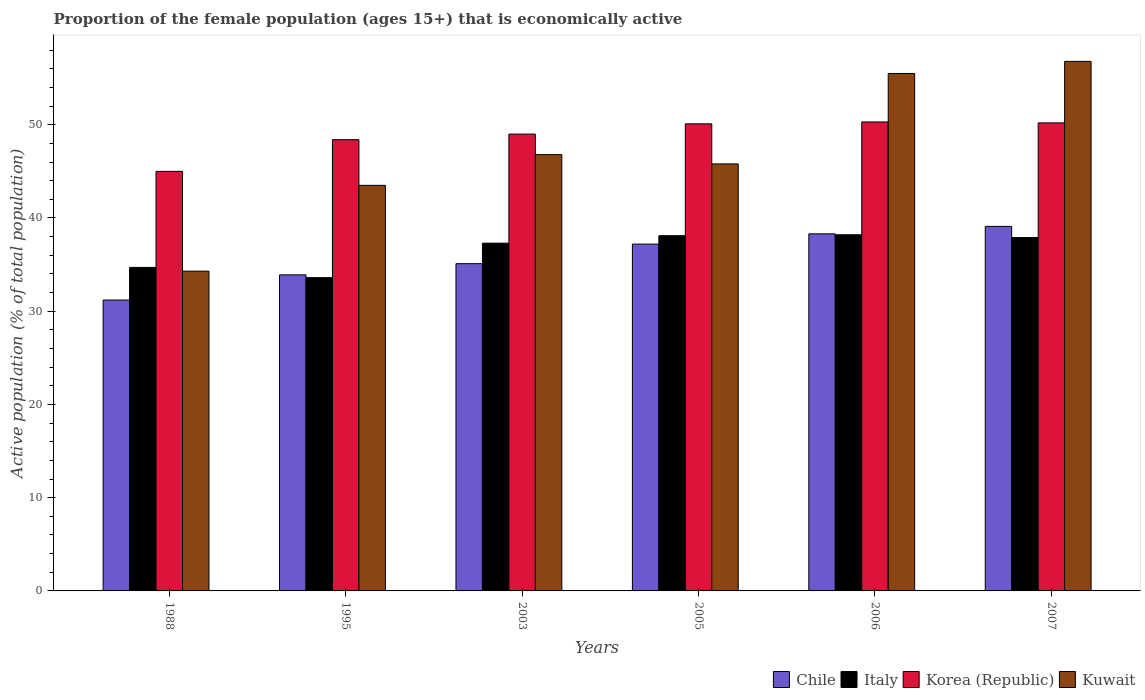Are the number of bars per tick equal to the number of legend labels?
Give a very brief answer. Yes. How many bars are there on the 1st tick from the right?
Your response must be concise. 4. In how many cases, is the number of bars for a given year not equal to the number of legend labels?
Ensure brevity in your answer.  0. What is the proportion of the female population that is economically active in Chile in 2006?
Keep it short and to the point. 38.3. Across all years, what is the maximum proportion of the female population that is economically active in Kuwait?
Offer a very short reply. 56.8. What is the total proportion of the female population that is economically active in Kuwait in the graph?
Provide a succinct answer. 282.7. What is the difference between the proportion of the female population that is economically active in Korea (Republic) in 2005 and that in 2006?
Provide a succinct answer. -0.2. What is the difference between the proportion of the female population that is economically active in Korea (Republic) in 2007 and the proportion of the female population that is economically active in Chile in 2005?
Your answer should be compact. 13. What is the average proportion of the female population that is economically active in Kuwait per year?
Your answer should be very brief. 47.12. In the year 2006, what is the difference between the proportion of the female population that is economically active in Kuwait and proportion of the female population that is economically active in Korea (Republic)?
Keep it short and to the point. 5.2. What is the ratio of the proportion of the female population that is economically active in Chile in 2006 to that in 2007?
Offer a terse response. 0.98. What is the difference between the highest and the second highest proportion of the female population that is economically active in Korea (Republic)?
Offer a very short reply. 0.1. What is the difference between the highest and the lowest proportion of the female population that is economically active in Italy?
Offer a terse response. 4.6. In how many years, is the proportion of the female population that is economically active in Chile greater than the average proportion of the female population that is economically active in Chile taken over all years?
Provide a short and direct response. 3. Is it the case that in every year, the sum of the proportion of the female population that is economically active in Kuwait and proportion of the female population that is economically active in Korea (Republic) is greater than the sum of proportion of the female population that is economically active in Italy and proportion of the female population that is economically active in Chile?
Offer a very short reply. No. What does the 4th bar from the left in 2006 represents?
Ensure brevity in your answer.  Kuwait. What does the 2nd bar from the right in 2007 represents?
Your response must be concise. Korea (Republic). Is it the case that in every year, the sum of the proportion of the female population that is economically active in Kuwait and proportion of the female population that is economically active in Italy is greater than the proportion of the female population that is economically active in Korea (Republic)?
Your answer should be very brief. Yes. How many bars are there?
Your response must be concise. 24. How many years are there in the graph?
Offer a very short reply. 6. What is the difference between two consecutive major ticks on the Y-axis?
Your response must be concise. 10. Does the graph contain any zero values?
Your answer should be compact. No. How are the legend labels stacked?
Provide a succinct answer. Horizontal. What is the title of the graph?
Provide a short and direct response. Proportion of the female population (ages 15+) that is economically active. Does "St. Martin (French part)" appear as one of the legend labels in the graph?
Provide a short and direct response. No. What is the label or title of the Y-axis?
Give a very brief answer. Active population (% of total population). What is the Active population (% of total population) in Chile in 1988?
Your response must be concise. 31.2. What is the Active population (% of total population) in Italy in 1988?
Keep it short and to the point. 34.7. What is the Active population (% of total population) in Kuwait in 1988?
Your response must be concise. 34.3. What is the Active population (% of total population) of Chile in 1995?
Provide a succinct answer. 33.9. What is the Active population (% of total population) in Italy in 1995?
Offer a very short reply. 33.6. What is the Active population (% of total population) in Korea (Republic) in 1995?
Provide a succinct answer. 48.4. What is the Active population (% of total population) of Kuwait in 1995?
Your response must be concise. 43.5. What is the Active population (% of total population) in Chile in 2003?
Provide a succinct answer. 35.1. What is the Active population (% of total population) in Italy in 2003?
Keep it short and to the point. 37.3. What is the Active population (% of total population) of Kuwait in 2003?
Offer a terse response. 46.8. What is the Active population (% of total population) in Chile in 2005?
Provide a short and direct response. 37.2. What is the Active population (% of total population) in Italy in 2005?
Give a very brief answer. 38.1. What is the Active population (% of total population) in Korea (Republic) in 2005?
Give a very brief answer. 50.1. What is the Active population (% of total population) of Kuwait in 2005?
Provide a short and direct response. 45.8. What is the Active population (% of total population) of Chile in 2006?
Keep it short and to the point. 38.3. What is the Active population (% of total population) in Italy in 2006?
Provide a short and direct response. 38.2. What is the Active population (% of total population) in Korea (Republic) in 2006?
Offer a very short reply. 50.3. What is the Active population (% of total population) of Kuwait in 2006?
Provide a short and direct response. 55.5. What is the Active population (% of total population) of Chile in 2007?
Make the answer very short. 39.1. What is the Active population (% of total population) of Italy in 2007?
Your answer should be compact. 37.9. What is the Active population (% of total population) in Korea (Republic) in 2007?
Make the answer very short. 50.2. What is the Active population (% of total population) of Kuwait in 2007?
Offer a very short reply. 56.8. Across all years, what is the maximum Active population (% of total population) of Chile?
Offer a very short reply. 39.1. Across all years, what is the maximum Active population (% of total population) in Italy?
Your answer should be very brief. 38.2. Across all years, what is the maximum Active population (% of total population) in Korea (Republic)?
Your answer should be very brief. 50.3. Across all years, what is the maximum Active population (% of total population) of Kuwait?
Your answer should be very brief. 56.8. Across all years, what is the minimum Active population (% of total population) of Chile?
Keep it short and to the point. 31.2. Across all years, what is the minimum Active population (% of total population) in Italy?
Give a very brief answer. 33.6. Across all years, what is the minimum Active population (% of total population) in Kuwait?
Offer a terse response. 34.3. What is the total Active population (% of total population) in Chile in the graph?
Keep it short and to the point. 214.8. What is the total Active population (% of total population) in Italy in the graph?
Make the answer very short. 219.8. What is the total Active population (% of total population) in Korea (Republic) in the graph?
Offer a very short reply. 293. What is the total Active population (% of total population) of Kuwait in the graph?
Ensure brevity in your answer.  282.7. What is the difference between the Active population (% of total population) in Chile in 1988 and that in 1995?
Make the answer very short. -2.7. What is the difference between the Active population (% of total population) of Korea (Republic) in 1988 and that in 1995?
Your response must be concise. -3.4. What is the difference between the Active population (% of total population) in Italy in 1988 and that in 2003?
Your answer should be very brief. -2.6. What is the difference between the Active population (% of total population) of Korea (Republic) in 1988 and that in 2003?
Your answer should be very brief. -4. What is the difference between the Active population (% of total population) of Kuwait in 1988 and that in 2003?
Provide a short and direct response. -12.5. What is the difference between the Active population (% of total population) of Korea (Republic) in 1988 and that in 2005?
Ensure brevity in your answer.  -5.1. What is the difference between the Active population (% of total population) of Kuwait in 1988 and that in 2005?
Provide a short and direct response. -11.5. What is the difference between the Active population (% of total population) of Italy in 1988 and that in 2006?
Give a very brief answer. -3.5. What is the difference between the Active population (% of total population) in Kuwait in 1988 and that in 2006?
Your answer should be compact. -21.2. What is the difference between the Active population (% of total population) in Italy in 1988 and that in 2007?
Provide a short and direct response. -3.2. What is the difference between the Active population (% of total population) in Kuwait in 1988 and that in 2007?
Make the answer very short. -22.5. What is the difference between the Active population (% of total population) in Chile in 1995 and that in 2003?
Offer a very short reply. -1.2. What is the difference between the Active population (% of total population) in Italy in 1995 and that in 2003?
Provide a short and direct response. -3.7. What is the difference between the Active population (% of total population) in Kuwait in 1995 and that in 2003?
Offer a terse response. -3.3. What is the difference between the Active population (% of total population) of Italy in 1995 and that in 2005?
Your response must be concise. -4.5. What is the difference between the Active population (% of total population) in Korea (Republic) in 1995 and that in 2005?
Make the answer very short. -1.7. What is the difference between the Active population (% of total population) in Italy in 1995 and that in 2006?
Ensure brevity in your answer.  -4.6. What is the difference between the Active population (% of total population) of Korea (Republic) in 1995 and that in 2006?
Offer a very short reply. -1.9. What is the difference between the Active population (% of total population) in Kuwait in 1995 and that in 2006?
Keep it short and to the point. -12. What is the difference between the Active population (% of total population) of Chile in 2003 and that in 2005?
Your answer should be very brief. -2.1. What is the difference between the Active population (% of total population) in Korea (Republic) in 2003 and that in 2006?
Ensure brevity in your answer.  -1.3. What is the difference between the Active population (% of total population) of Italy in 2003 and that in 2007?
Give a very brief answer. -0.6. What is the difference between the Active population (% of total population) of Korea (Republic) in 2003 and that in 2007?
Provide a short and direct response. -1.2. What is the difference between the Active population (% of total population) in Chile in 2005 and that in 2006?
Provide a short and direct response. -1.1. What is the difference between the Active population (% of total population) in Korea (Republic) in 2005 and that in 2006?
Offer a very short reply. -0.2. What is the difference between the Active population (% of total population) of Chile in 2005 and that in 2007?
Keep it short and to the point. -1.9. What is the difference between the Active population (% of total population) of Italy in 2005 and that in 2007?
Keep it short and to the point. 0.2. What is the difference between the Active population (% of total population) of Kuwait in 2005 and that in 2007?
Provide a short and direct response. -11. What is the difference between the Active population (% of total population) in Italy in 2006 and that in 2007?
Make the answer very short. 0.3. What is the difference between the Active population (% of total population) of Korea (Republic) in 2006 and that in 2007?
Provide a succinct answer. 0.1. What is the difference between the Active population (% of total population) in Chile in 1988 and the Active population (% of total population) in Italy in 1995?
Provide a short and direct response. -2.4. What is the difference between the Active population (% of total population) in Chile in 1988 and the Active population (% of total population) in Korea (Republic) in 1995?
Offer a very short reply. -17.2. What is the difference between the Active population (% of total population) of Italy in 1988 and the Active population (% of total population) of Korea (Republic) in 1995?
Make the answer very short. -13.7. What is the difference between the Active population (% of total population) of Korea (Republic) in 1988 and the Active population (% of total population) of Kuwait in 1995?
Offer a terse response. 1.5. What is the difference between the Active population (% of total population) of Chile in 1988 and the Active population (% of total population) of Korea (Republic) in 2003?
Provide a short and direct response. -17.8. What is the difference between the Active population (% of total population) in Chile in 1988 and the Active population (% of total population) in Kuwait in 2003?
Provide a short and direct response. -15.6. What is the difference between the Active population (% of total population) in Italy in 1988 and the Active population (% of total population) in Korea (Republic) in 2003?
Your answer should be compact. -14.3. What is the difference between the Active population (% of total population) in Korea (Republic) in 1988 and the Active population (% of total population) in Kuwait in 2003?
Give a very brief answer. -1.8. What is the difference between the Active population (% of total population) of Chile in 1988 and the Active population (% of total population) of Korea (Republic) in 2005?
Your response must be concise. -18.9. What is the difference between the Active population (% of total population) of Chile in 1988 and the Active population (% of total population) of Kuwait in 2005?
Offer a terse response. -14.6. What is the difference between the Active population (% of total population) of Italy in 1988 and the Active population (% of total population) of Korea (Republic) in 2005?
Provide a short and direct response. -15.4. What is the difference between the Active population (% of total population) of Chile in 1988 and the Active population (% of total population) of Korea (Republic) in 2006?
Your answer should be very brief. -19.1. What is the difference between the Active population (% of total population) of Chile in 1988 and the Active population (% of total population) of Kuwait in 2006?
Keep it short and to the point. -24.3. What is the difference between the Active population (% of total population) of Italy in 1988 and the Active population (% of total population) of Korea (Republic) in 2006?
Keep it short and to the point. -15.6. What is the difference between the Active population (% of total population) in Italy in 1988 and the Active population (% of total population) in Kuwait in 2006?
Your answer should be compact. -20.8. What is the difference between the Active population (% of total population) in Chile in 1988 and the Active population (% of total population) in Italy in 2007?
Your response must be concise. -6.7. What is the difference between the Active population (% of total population) in Chile in 1988 and the Active population (% of total population) in Kuwait in 2007?
Provide a succinct answer. -25.6. What is the difference between the Active population (% of total population) in Italy in 1988 and the Active population (% of total population) in Korea (Republic) in 2007?
Your response must be concise. -15.5. What is the difference between the Active population (% of total population) of Italy in 1988 and the Active population (% of total population) of Kuwait in 2007?
Your response must be concise. -22.1. What is the difference between the Active population (% of total population) of Chile in 1995 and the Active population (% of total population) of Korea (Republic) in 2003?
Your answer should be very brief. -15.1. What is the difference between the Active population (% of total population) in Chile in 1995 and the Active population (% of total population) in Kuwait in 2003?
Provide a succinct answer. -12.9. What is the difference between the Active population (% of total population) in Italy in 1995 and the Active population (% of total population) in Korea (Republic) in 2003?
Give a very brief answer. -15.4. What is the difference between the Active population (% of total population) in Chile in 1995 and the Active population (% of total population) in Korea (Republic) in 2005?
Your answer should be compact. -16.2. What is the difference between the Active population (% of total population) of Italy in 1995 and the Active population (% of total population) of Korea (Republic) in 2005?
Your answer should be compact. -16.5. What is the difference between the Active population (% of total population) of Chile in 1995 and the Active population (% of total population) of Korea (Republic) in 2006?
Offer a very short reply. -16.4. What is the difference between the Active population (% of total population) of Chile in 1995 and the Active population (% of total population) of Kuwait in 2006?
Your answer should be very brief. -21.6. What is the difference between the Active population (% of total population) of Italy in 1995 and the Active population (% of total population) of Korea (Republic) in 2006?
Provide a short and direct response. -16.7. What is the difference between the Active population (% of total population) in Italy in 1995 and the Active population (% of total population) in Kuwait in 2006?
Ensure brevity in your answer.  -21.9. What is the difference between the Active population (% of total population) in Korea (Republic) in 1995 and the Active population (% of total population) in Kuwait in 2006?
Keep it short and to the point. -7.1. What is the difference between the Active population (% of total population) in Chile in 1995 and the Active population (% of total population) in Italy in 2007?
Offer a very short reply. -4. What is the difference between the Active population (% of total population) of Chile in 1995 and the Active population (% of total population) of Korea (Republic) in 2007?
Give a very brief answer. -16.3. What is the difference between the Active population (% of total population) of Chile in 1995 and the Active population (% of total population) of Kuwait in 2007?
Provide a succinct answer. -22.9. What is the difference between the Active population (% of total population) of Italy in 1995 and the Active population (% of total population) of Korea (Republic) in 2007?
Offer a terse response. -16.6. What is the difference between the Active population (% of total population) in Italy in 1995 and the Active population (% of total population) in Kuwait in 2007?
Keep it short and to the point. -23.2. What is the difference between the Active population (% of total population) of Korea (Republic) in 1995 and the Active population (% of total population) of Kuwait in 2007?
Your answer should be very brief. -8.4. What is the difference between the Active population (% of total population) of Chile in 2003 and the Active population (% of total population) of Italy in 2005?
Ensure brevity in your answer.  -3. What is the difference between the Active population (% of total population) in Chile in 2003 and the Active population (% of total population) in Kuwait in 2005?
Your response must be concise. -10.7. What is the difference between the Active population (% of total population) of Italy in 2003 and the Active population (% of total population) of Kuwait in 2005?
Provide a succinct answer. -8.5. What is the difference between the Active population (% of total population) of Chile in 2003 and the Active population (% of total population) of Italy in 2006?
Ensure brevity in your answer.  -3.1. What is the difference between the Active population (% of total population) in Chile in 2003 and the Active population (% of total population) in Korea (Republic) in 2006?
Ensure brevity in your answer.  -15.2. What is the difference between the Active population (% of total population) in Chile in 2003 and the Active population (% of total population) in Kuwait in 2006?
Offer a very short reply. -20.4. What is the difference between the Active population (% of total population) in Italy in 2003 and the Active population (% of total population) in Korea (Republic) in 2006?
Make the answer very short. -13. What is the difference between the Active population (% of total population) in Italy in 2003 and the Active population (% of total population) in Kuwait in 2006?
Give a very brief answer. -18.2. What is the difference between the Active population (% of total population) in Chile in 2003 and the Active population (% of total population) in Korea (Republic) in 2007?
Your answer should be compact. -15.1. What is the difference between the Active population (% of total population) of Chile in 2003 and the Active population (% of total population) of Kuwait in 2007?
Your response must be concise. -21.7. What is the difference between the Active population (% of total population) of Italy in 2003 and the Active population (% of total population) of Kuwait in 2007?
Your answer should be compact. -19.5. What is the difference between the Active population (% of total population) in Chile in 2005 and the Active population (% of total population) in Korea (Republic) in 2006?
Ensure brevity in your answer.  -13.1. What is the difference between the Active population (% of total population) of Chile in 2005 and the Active population (% of total population) of Kuwait in 2006?
Ensure brevity in your answer.  -18.3. What is the difference between the Active population (% of total population) in Italy in 2005 and the Active population (% of total population) in Korea (Republic) in 2006?
Give a very brief answer. -12.2. What is the difference between the Active population (% of total population) of Italy in 2005 and the Active population (% of total population) of Kuwait in 2006?
Provide a short and direct response. -17.4. What is the difference between the Active population (% of total population) of Chile in 2005 and the Active population (% of total population) of Korea (Republic) in 2007?
Ensure brevity in your answer.  -13. What is the difference between the Active population (% of total population) in Chile in 2005 and the Active population (% of total population) in Kuwait in 2007?
Offer a very short reply. -19.6. What is the difference between the Active population (% of total population) of Italy in 2005 and the Active population (% of total population) of Kuwait in 2007?
Offer a terse response. -18.7. What is the difference between the Active population (% of total population) in Korea (Republic) in 2005 and the Active population (% of total population) in Kuwait in 2007?
Provide a short and direct response. -6.7. What is the difference between the Active population (% of total population) in Chile in 2006 and the Active population (% of total population) in Italy in 2007?
Provide a succinct answer. 0.4. What is the difference between the Active population (% of total population) of Chile in 2006 and the Active population (% of total population) of Korea (Republic) in 2007?
Your answer should be very brief. -11.9. What is the difference between the Active population (% of total population) of Chile in 2006 and the Active population (% of total population) of Kuwait in 2007?
Give a very brief answer. -18.5. What is the difference between the Active population (% of total population) in Italy in 2006 and the Active population (% of total population) in Kuwait in 2007?
Offer a terse response. -18.6. What is the difference between the Active population (% of total population) in Korea (Republic) in 2006 and the Active population (% of total population) in Kuwait in 2007?
Keep it short and to the point. -6.5. What is the average Active population (% of total population) in Chile per year?
Provide a succinct answer. 35.8. What is the average Active population (% of total population) of Italy per year?
Provide a succinct answer. 36.63. What is the average Active population (% of total population) in Korea (Republic) per year?
Provide a succinct answer. 48.83. What is the average Active population (% of total population) of Kuwait per year?
Your answer should be very brief. 47.12. In the year 1988, what is the difference between the Active population (% of total population) in Chile and Active population (% of total population) in Italy?
Keep it short and to the point. -3.5. In the year 1988, what is the difference between the Active population (% of total population) of Chile and Active population (% of total population) of Kuwait?
Make the answer very short. -3.1. In the year 1988, what is the difference between the Active population (% of total population) in Italy and Active population (% of total population) in Korea (Republic)?
Your answer should be very brief. -10.3. In the year 1995, what is the difference between the Active population (% of total population) in Chile and Active population (% of total population) in Korea (Republic)?
Ensure brevity in your answer.  -14.5. In the year 1995, what is the difference between the Active population (% of total population) of Chile and Active population (% of total population) of Kuwait?
Keep it short and to the point. -9.6. In the year 1995, what is the difference between the Active population (% of total population) in Italy and Active population (% of total population) in Korea (Republic)?
Your answer should be very brief. -14.8. In the year 1995, what is the difference between the Active population (% of total population) of Korea (Republic) and Active population (% of total population) of Kuwait?
Provide a succinct answer. 4.9. In the year 2003, what is the difference between the Active population (% of total population) in Chile and Active population (% of total population) in Italy?
Your response must be concise. -2.2. In the year 2003, what is the difference between the Active population (% of total population) of Italy and Active population (% of total population) of Korea (Republic)?
Ensure brevity in your answer.  -11.7. In the year 2003, what is the difference between the Active population (% of total population) in Italy and Active population (% of total population) in Kuwait?
Your answer should be compact. -9.5. In the year 2003, what is the difference between the Active population (% of total population) in Korea (Republic) and Active population (% of total population) in Kuwait?
Your response must be concise. 2.2. In the year 2006, what is the difference between the Active population (% of total population) in Chile and Active population (% of total population) in Korea (Republic)?
Offer a terse response. -12. In the year 2006, what is the difference between the Active population (% of total population) in Chile and Active population (% of total population) in Kuwait?
Offer a very short reply. -17.2. In the year 2006, what is the difference between the Active population (% of total population) of Italy and Active population (% of total population) of Kuwait?
Keep it short and to the point. -17.3. In the year 2007, what is the difference between the Active population (% of total population) in Chile and Active population (% of total population) in Italy?
Your answer should be compact. 1.2. In the year 2007, what is the difference between the Active population (% of total population) in Chile and Active population (% of total population) in Korea (Republic)?
Provide a succinct answer. -11.1. In the year 2007, what is the difference between the Active population (% of total population) in Chile and Active population (% of total population) in Kuwait?
Provide a succinct answer. -17.7. In the year 2007, what is the difference between the Active population (% of total population) in Italy and Active population (% of total population) in Kuwait?
Give a very brief answer. -18.9. In the year 2007, what is the difference between the Active population (% of total population) in Korea (Republic) and Active population (% of total population) in Kuwait?
Your answer should be compact. -6.6. What is the ratio of the Active population (% of total population) of Chile in 1988 to that in 1995?
Provide a succinct answer. 0.92. What is the ratio of the Active population (% of total population) in Italy in 1988 to that in 1995?
Your answer should be compact. 1.03. What is the ratio of the Active population (% of total population) in Korea (Republic) in 1988 to that in 1995?
Provide a succinct answer. 0.93. What is the ratio of the Active population (% of total population) of Kuwait in 1988 to that in 1995?
Ensure brevity in your answer.  0.79. What is the ratio of the Active population (% of total population) in Italy in 1988 to that in 2003?
Make the answer very short. 0.93. What is the ratio of the Active population (% of total population) in Korea (Republic) in 1988 to that in 2003?
Ensure brevity in your answer.  0.92. What is the ratio of the Active population (% of total population) in Kuwait in 1988 to that in 2003?
Provide a succinct answer. 0.73. What is the ratio of the Active population (% of total population) of Chile in 1988 to that in 2005?
Provide a succinct answer. 0.84. What is the ratio of the Active population (% of total population) of Italy in 1988 to that in 2005?
Provide a short and direct response. 0.91. What is the ratio of the Active population (% of total population) of Korea (Republic) in 1988 to that in 2005?
Provide a short and direct response. 0.9. What is the ratio of the Active population (% of total population) in Kuwait in 1988 to that in 2005?
Make the answer very short. 0.75. What is the ratio of the Active population (% of total population) in Chile in 1988 to that in 2006?
Give a very brief answer. 0.81. What is the ratio of the Active population (% of total population) of Italy in 1988 to that in 2006?
Your response must be concise. 0.91. What is the ratio of the Active population (% of total population) in Korea (Republic) in 1988 to that in 2006?
Keep it short and to the point. 0.89. What is the ratio of the Active population (% of total population) of Kuwait in 1988 to that in 2006?
Make the answer very short. 0.62. What is the ratio of the Active population (% of total population) in Chile in 1988 to that in 2007?
Make the answer very short. 0.8. What is the ratio of the Active population (% of total population) of Italy in 1988 to that in 2007?
Offer a very short reply. 0.92. What is the ratio of the Active population (% of total population) in Korea (Republic) in 1988 to that in 2007?
Your answer should be very brief. 0.9. What is the ratio of the Active population (% of total population) in Kuwait in 1988 to that in 2007?
Provide a succinct answer. 0.6. What is the ratio of the Active population (% of total population) of Chile in 1995 to that in 2003?
Give a very brief answer. 0.97. What is the ratio of the Active population (% of total population) in Italy in 1995 to that in 2003?
Provide a short and direct response. 0.9. What is the ratio of the Active population (% of total population) in Korea (Republic) in 1995 to that in 2003?
Offer a very short reply. 0.99. What is the ratio of the Active population (% of total population) in Kuwait in 1995 to that in 2003?
Provide a succinct answer. 0.93. What is the ratio of the Active population (% of total population) of Chile in 1995 to that in 2005?
Provide a short and direct response. 0.91. What is the ratio of the Active population (% of total population) in Italy in 1995 to that in 2005?
Keep it short and to the point. 0.88. What is the ratio of the Active population (% of total population) of Korea (Republic) in 1995 to that in 2005?
Keep it short and to the point. 0.97. What is the ratio of the Active population (% of total population) of Kuwait in 1995 to that in 2005?
Your answer should be compact. 0.95. What is the ratio of the Active population (% of total population) in Chile in 1995 to that in 2006?
Your response must be concise. 0.89. What is the ratio of the Active population (% of total population) of Italy in 1995 to that in 2006?
Keep it short and to the point. 0.88. What is the ratio of the Active population (% of total population) of Korea (Republic) in 1995 to that in 2006?
Offer a terse response. 0.96. What is the ratio of the Active population (% of total population) of Kuwait in 1995 to that in 2006?
Provide a succinct answer. 0.78. What is the ratio of the Active population (% of total population) of Chile in 1995 to that in 2007?
Provide a short and direct response. 0.87. What is the ratio of the Active population (% of total population) of Italy in 1995 to that in 2007?
Provide a short and direct response. 0.89. What is the ratio of the Active population (% of total population) in Korea (Republic) in 1995 to that in 2007?
Your answer should be compact. 0.96. What is the ratio of the Active population (% of total population) of Kuwait in 1995 to that in 2007?
Offer a very short reply. 0.77. What is the ratio of the Active population (% of total population) in Chile in 2003 to that in 2005?
Offer a terse response. 0.94. What is the ratio of the Active population (% of total population) of Korea (Republic) in 2003 to that in 2005?
Keep it short and to the point. 0.98. What is the ratio of the Active population (% of total population) in Kuwait in 2003 to that in 2005?
Keep it short and to the point. 1.02. What is the ratio of the Active population (% of total population) in Chile in 2003 to that in 2006?
Ensure brevity in your answer.  0.92. What is the ratio of the Active population (% of total population) in Italy in 2003 to that in 2006?
Keep it short and to the point. 0.98. What is the ratio of the Active population (% of total population) of Korea (Republic) in 2003 to that in 2006?
Offer a very short reply. 0.97. What is the ratio of the Active population (% of total population) of Kuwait in 2003 to that in 2006?
Provide a short and direct response. 0.84. What is the ratio of the Active population (% of total population) of Chile in 2003 to that in 2007?
Offer a terse response. 0.9. What is the ratio of the Active population (% of total population) in Italy in 2003 to that in 2007?
Your answer should be very brief. 0.98. What is the ratio of the Active population (% of total population) of Korea (Republic) in 2003 to that in 2007?
Your answer should be very brief. 0.98. What is the ratio of the Active population (% of total population) of Kuwait in 2003 to that in 2007?
Your response must be concise. 0.82. What is the ratio of the Active population (% of total population) of Chile in 2005 to that in 2006?
Your answer should be compact. 0.97. What is the ratio of the Active population (% of total population) in Italy in 2005 to that in 2006?
Provide a succinct answer. 1. What is the ratio of the Active population (% of total population) of Kuwait in 2005 to that in 2006?
Make the answer very short. 0.83. What is the ratio of the Active population (% of total population) of Chile in 2005 to that in 2007?
Your answer should be very brief. 0.95. What is the ratio of the Active population (% of total population) of Italy in 2005 to that in 2007?
Your response must be concise. 1.01. What is the ratio of the Active population (% of total population) in Korea (Republic) in 2005 to that in 2007?
Your answer should be compact. 1. What is the ratio of the Active population (% of total population) in Kuwait in 2005 to that in 2007?
Offer a terse response. 0.81. What is the ratio of the Active population (% of total population) in Chile in 2006 to that in 2007?
Your answer should be compact. 0.98. What is the ratio of the Active population (% of total population) in Italy in 2006 to that in 2007?
Your response must be concise. 1.01. What is the ratio of the Active population (% of total population) in Korea (Republic) in 2006 to that in 2007?
Offer a terse response. 1. What is the ratio of the Active population (% of total population) in Kuwait in 2006 to that in 2007?
Provide a short and direct response. 0.98. What is the difference between the highest and the second highest Active population (% of total population) of Chile?
Give a very brief answer. 0.8. What is the difference between the highest and the second highest Active population (% of total population) in Italy?
Provide a short and direct response. 0.1. What is the difference between the highest and the lowest Active population (% of total population) in Italy?
Your response must be concise. 4.6. What is the difference between the highest and the lowest Active population (% of total population) of Kuwait?
Keep it short and to the point. 22.5. 